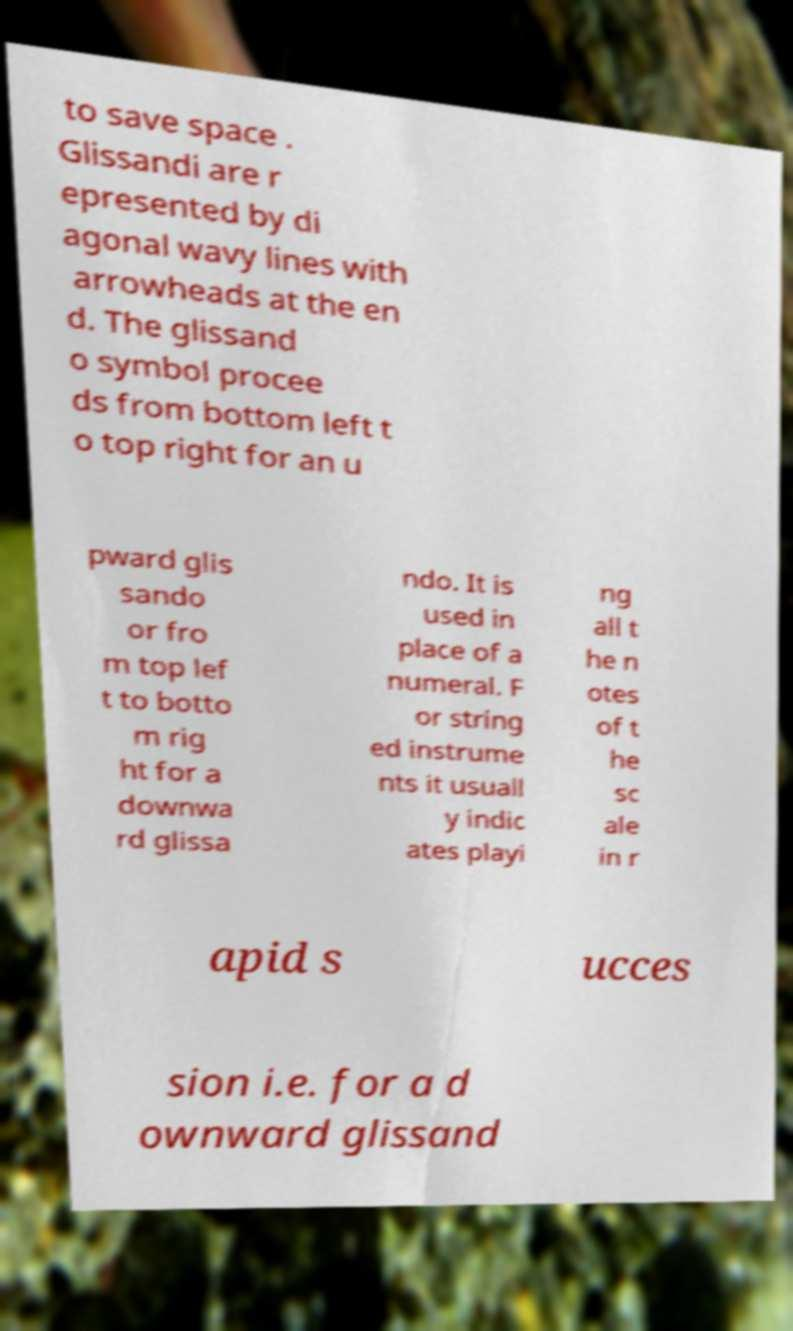Please read and relay the text visible in this image. What does it say? to save space . Glissandi are r epresented by di agonal wavy lines with arrowheads at the en d. The glissand o symbol procee ds from bottom left t o top right for an u pward glis sando or fro m top lef t to botto m rig ht for a downwa rd glissa ndo. It is used in place of a numeral. F or string ed instrume nts it usuall y indic ates playi ng all t he n otes of t he sc ale in r apid s ucces sion i.e. for a d ownward glissand 